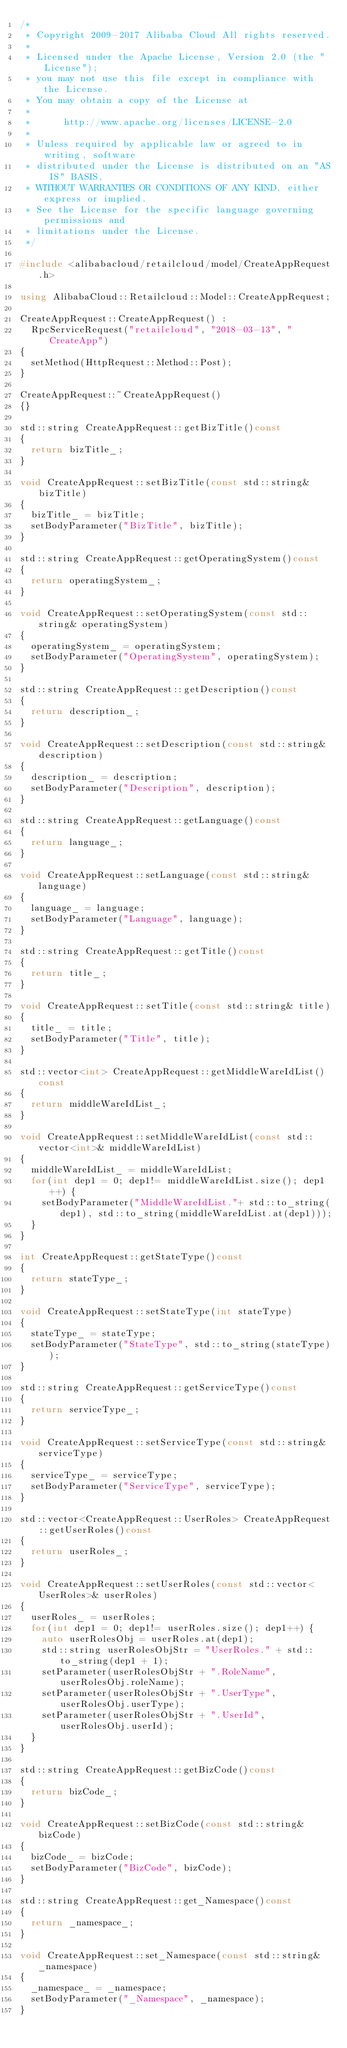<code> <loc_0><loc_0><loc_500><loc_500><_C++_>/*
 * Copyright 2009-2017 Alibaba Cloud All rights reserved.
 * 
 * Licensed under the Apache License, Version 2.0 (the "License");
 * you may not use this file except in compliance with the License.
 * You may obtain a copy of the License at
 * 
 *      http://www.apache.org/licenses/LICENSE-2.0
 * 
 * Unless required by applicable law or agreed to in writing, software
 * distributed under the License is distributed on an "AS IS" BASIS,
 * WITHOUT WARRANTIES OR CONDITIONS OF ANY KIND, either express or implied.
 * See the License for the specific language governing permissions and
 * limitations under the License.
 */

#include <alibabacloud/retailcloud/model/CreateAppRequest.h>

using AlibabaCloud::Retailcloud::Model::CreateAppRequest;

CreateAppRequest::CreateAppRequest() :
	RpcServiceRequest("retailcloud", "2018-03-13", "CreateApp")
{
	setMethod(HttpRequest::Method::Post);
}

CreateAppRequest::~CreateAppRequest()
{}

std::string CreateAppRequest::getBizTitle()const
{
	return bizTitle_;
}

void CreateAppRequest::setBizTitle(const std::string& bizTitle)
{
	bizTitle_ = bizTitle;
	setBodyParameter("BizTitle", bizTitle);
}

std::string CreateAppRequest::getOperatingSystem()const
{
	return operatingSystem_;
}

void CreateAppRequest::setOperatingSystem(const std::string& operatingSystem)
{
	operatingSystem_ = operatingSystem;
	setBodyParameter("OperatingSystem", operatingSystem);
}

std::string CreateAppRequest::getDescription()const
{
	return description_;
}

void CreateAppRequest::setDescription(const std::string& description)
{
	description_ = description;
	setBodyParameter("Description", description);
}

std::string CreateAppRequest::getLanguage()const
{
	return language_;
}

void CreateAppRequest::setLanguage(const std::string& language)
{
	language_ = language;
	setBodyParameter("Language", language);
}

std::string CreateAppRequest::getTitle()const
{
	return title_;
}

void CreateAppRequest::setTitle(const std::string& title)
{
	title_ = title;
	setBodyParameter("Title", title);
}

std::vector<int> CreateAppRequest::getMiddleWareIdList()const
{
	return middleWareIdList_;
}

void CreateAppRequest::setMiddleWareIdList(const std::vector<int>& middleWareIdList)
{
	middleWareIdList_ = middleWareIdList;
	for(int dep1 = 0; dep1!= middleWareIdList.size(); dep1++) {
		setBodyParameter("MiddleWareIdList."+ std::to_string(dep1), std::to_string(middleWareIdList.at(dep1)));
	}
}

int CreateAppRequest::getStateType()const
{
	return stateType_;
}

void CreateAppRequest::setStateType(int stateType)
{
	stateType_ = stateType;
	setBodyParameter("StateType", std::to_string(stateType));
}

std::string CreateAppRequest::getServiceType()const
{
	return serviceType_;
}

void CreateAppRequest::setServiceType(const std::string& serviceType)
{
	serviceType_ = serviceType;
	setBodyParameter("ServiceType", serviceType);
}

std::vector<CreateAppRequest::UserRoles> CreateAppRequest::getUserRoles()const
{
	return userRoles_;
}

void CreateAppRequest::setUserRoles(const std::vector<UserRoles>& userRoles)
{
	userRoles_ = userRoles;
	for(int dep1 = 0; dep1!= userRoles.size(); dep1++) {
		auto userRolesObj = userRoles.at(dep1);
		std::string userRolesObjStr = "UserRoles." + std::to_string(dep1 + 1);
		setParameter(userRolesObjStr + ".RoleName", userRolesObj.roleName);
		setParameter(userRolesObjStr + ".UserType", userRolesObj.userType);
		setParameter(userRolesObjStr + ".UserId", userRolesObj.userId);
	}
}

std::string CreateAppRequest::getBizCode()const
{
	return bizCode_;
}

void CreateAppRequest::setBizCode(const std::string& bizCode)
{
	bizCode_ = bizCode;
	setBodyParameter("BizCode", bizCode);
}

std::string CreateAppRequest::get_Namespace()const
{
	return _namespace_;
}

void CreateAppRequest::set_Namespace(const std::string& _namespace)
{
	_namespace_ = _namespace;
	setBodyParameter("_Namespace", _namespace);
}

</code> 